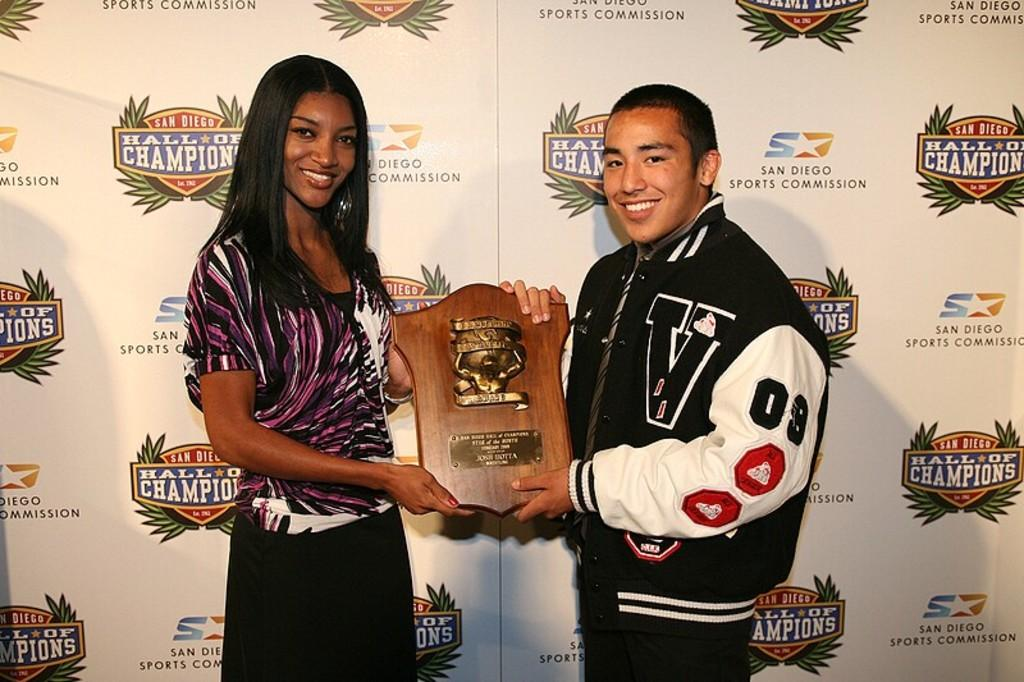<image>
Render a clear and concise summary of the photo. two people holding a plack for the hall of champions 